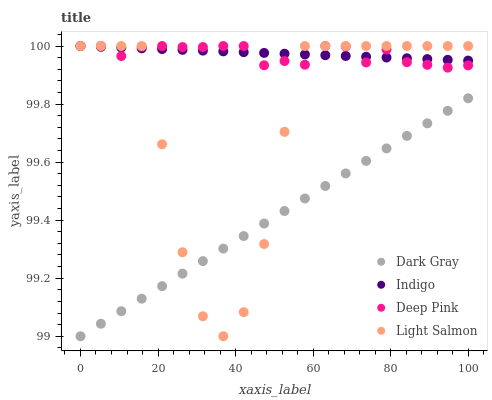Does Dark Gray have the minimum area under the curve?
Answer yes or no. Yes. Does Indigo have the maximum area under the curve?
Answer yes or no. Yes. Does Light Salmon have the minimum area under the curve?
Answer yes or no. No. Does Light Salmon have the maximum area under the curve?
Answer yes or no. No. Is Dark Gray the smoothest?
Answer yes or no. Yes. Is Light Salmon the roughest?
Answer yes or no. Yes. Is Deep Pink the smoothest?
Answer yes or no. No. Is Deep Pink the roughest?
Answer yes or no. No. Does Dark Gray have the lowest value?
Answer yes or no. Yes. Does Light Salmon have the lowest value?
Answer yes or no. No. Does Indigo have the highest value?
Answer yes or no. Yes. Is Dark Gray less than Deep Pink?
Answer yes or no. Yes. Is Indigo greater than Dark Gray?
Answer yes or no. Yes. Does Light Salmon intersect Dark Gray?
Answer yes or no. Yes. Is Light Salmon less than Dark Gray?
Answer yes or no. No. Is Light Salmon greater than Dark Gray?
Answer yes or no. No. Does Dark Gray intersect Deep Pink?
Answer yes or no. No. 